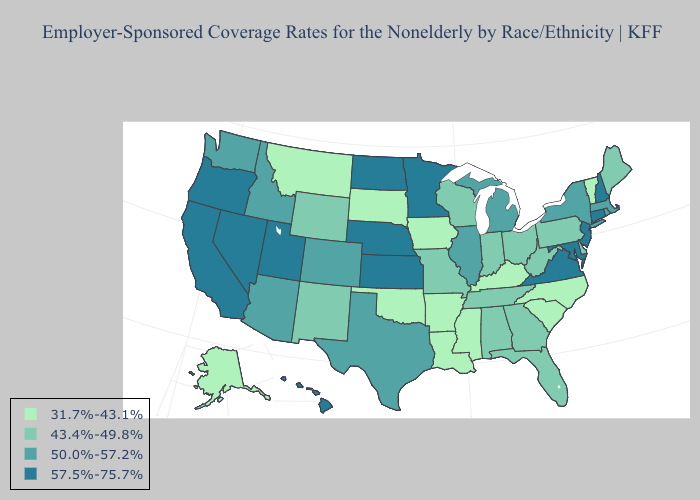Is the legend a continuous bar?
Short answer required. No. Name the states that have a value in the range 43.4%-49.8%?
Short answer required. Alabama, Delaware, Florida, Georgia, Indiana, Maine, Missouri, New Mexico, Ohio, Pennsylvania, Tennessee, West Virginia, Wisconsin, Wyoming. Does Vermont have the highest value in the Northeast?
Concise answer only. No. Among the states that border Wyoming , does Idaho have the highest value?
Answer briefly. No. Among the states that border California , does Arizona have the lowest value?
Quick response, please. Yes. Which states hav the highest value in the MidWest?
Concise answer only. Kansas, Minnesota, Nebraska, North Dakota. Among the states that border Delaware , which have the lowest value?
Answer briefly. Pennsylvania. What is the value of Maryland?
Short answer required. 57.5%-75.7%. Name the states that have a value in the range 50.0%-57.2%?
Answer briefly. Arizona, Colorado, Idaho, Illinois, Massachusetts, Michigan, New York, Rhode Island, Texas, Washington. What is the value of Utah?
Keep it brief. 57.5%-75.7%. What is the highest value in the Northeast ?
Quick response, please. 57.5%-75.7%. What is the value of Vermont?
Answer briefly. 31.7%-43.1%. What is the value of Wyoming?
Write a very short answer. 43.4%-49.8%. Does the first symbol in the legend represent the smallest category?
Quick response, please. Yes. Does Nebraska have the lowest value in the USA?
Give a very brief answer. No. 